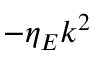Convert formula to latex. <formula><loc_0><loc_0><loc_500><loc_500>- \eta _ { E } k ^ { 2 }</formula> 